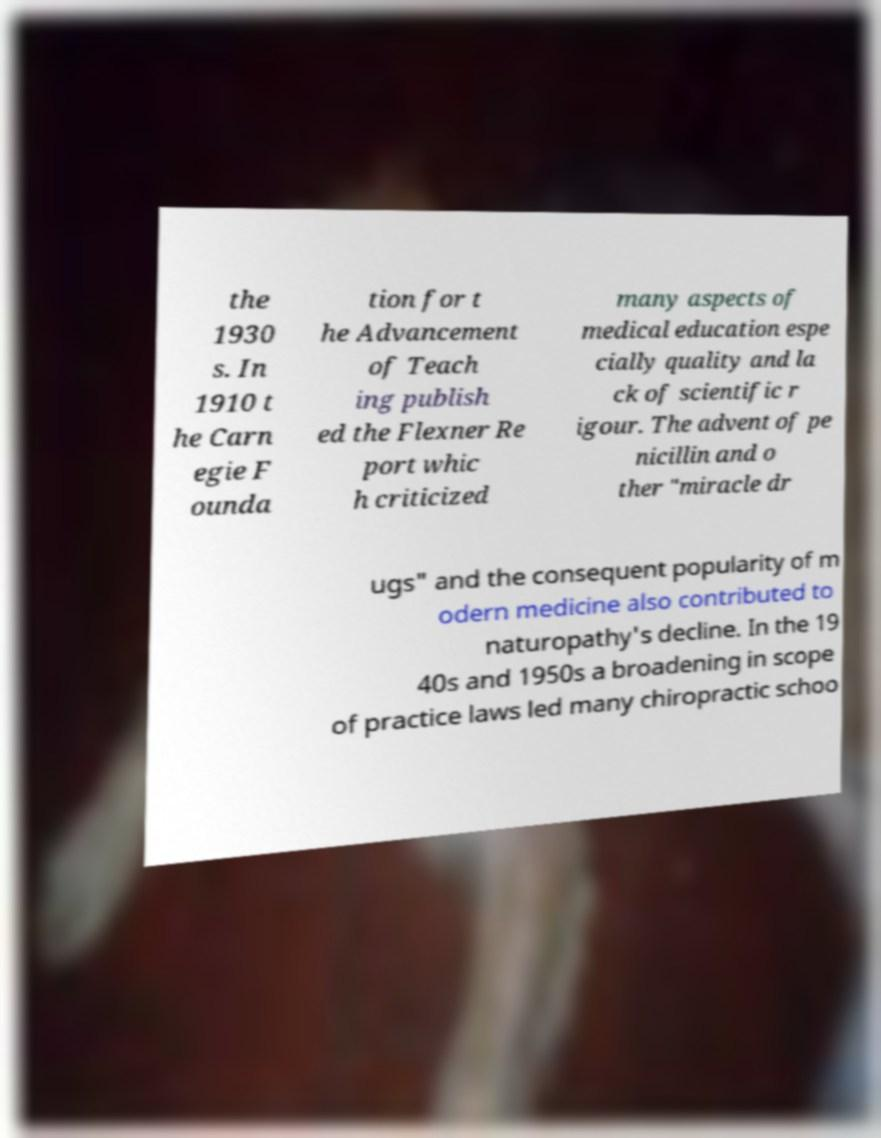Please read and relay the text visible in this image. What does it say? the 1930 s. In 1910 t he Carn egie F ounda tion for t he Advancement of Teach ing publish ed the Flexner Re port whic h criticized many aspects of medical education espe cially quality and la ck of scientific r igour. The advent of pe nicillin and o ther "miracle dr ugs" and the consequent popularity of m odern medicine also contributed to naturopathy's decline. In the 19 40s and 1950s a broadening in scope of practice laws led many chiropractic schoo 